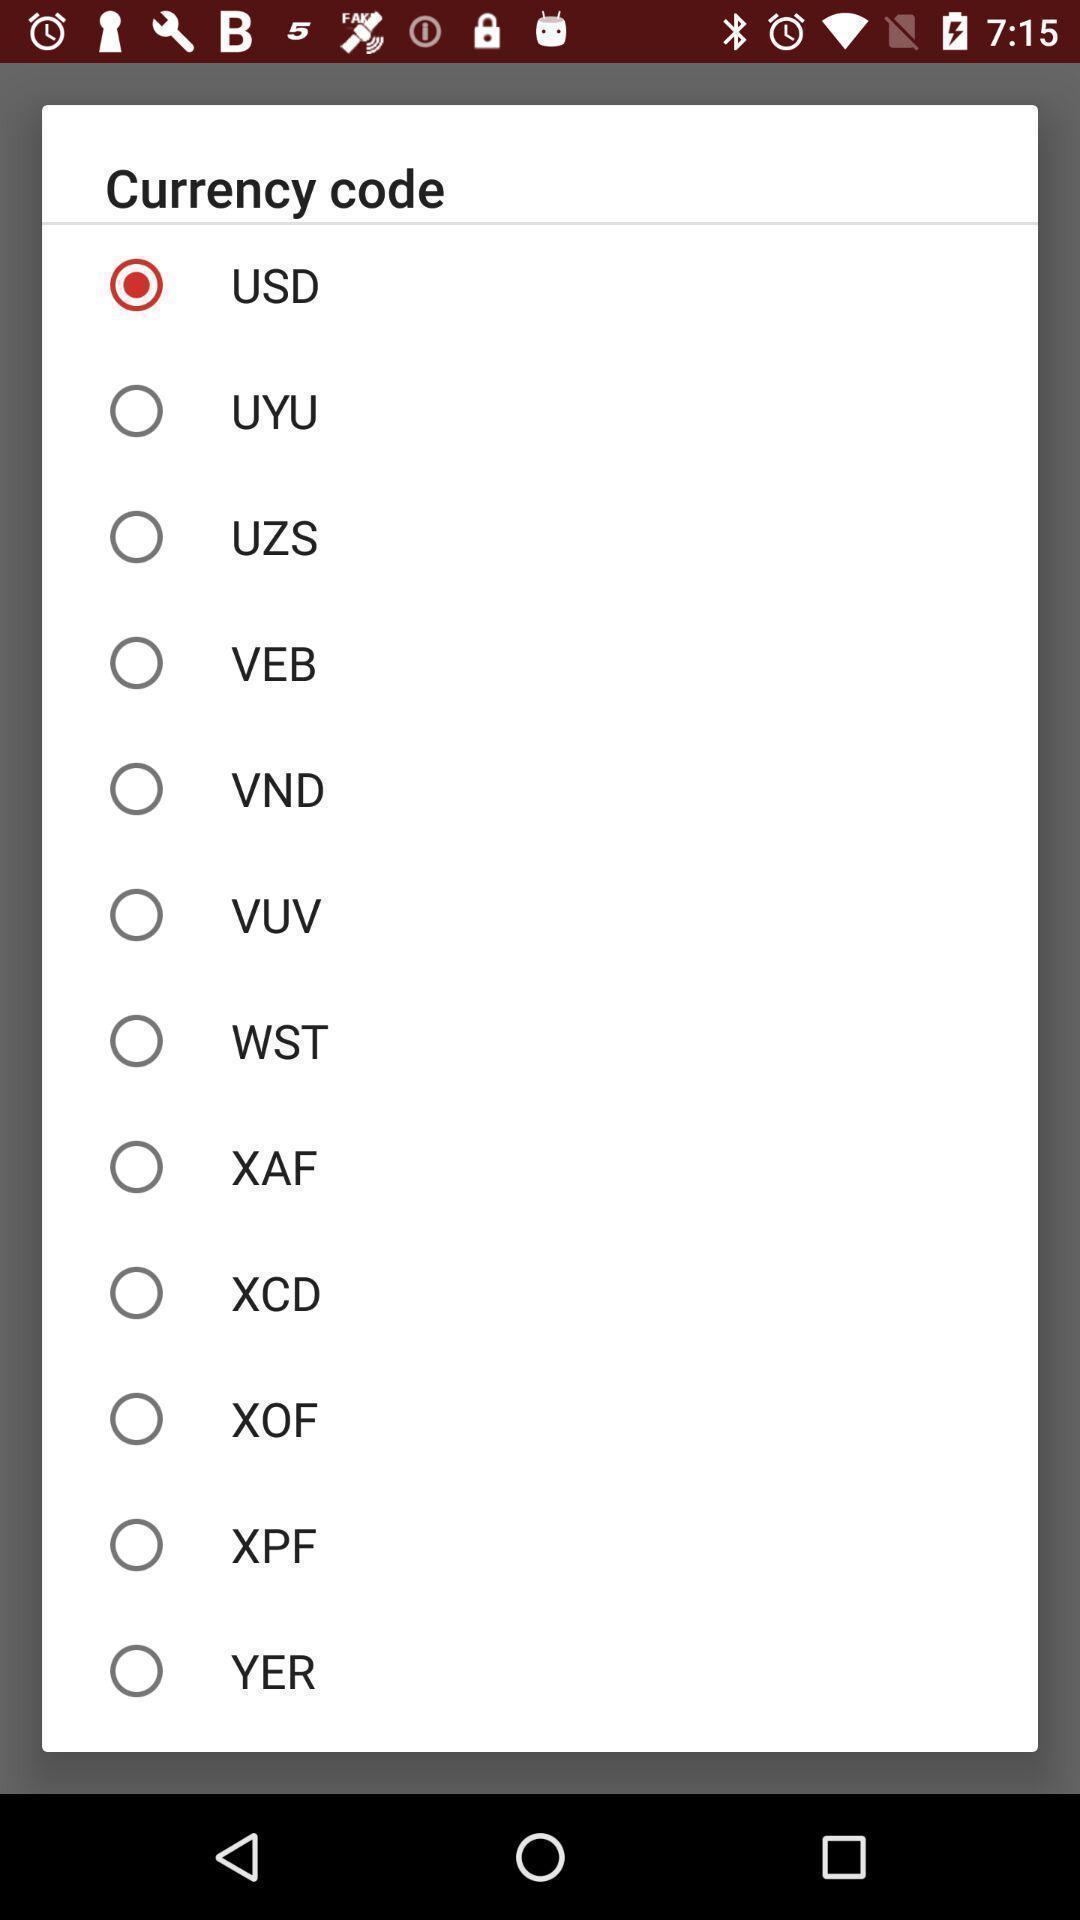Tell me about the visual elements in this screen capture. Popup showing about different currency code. 